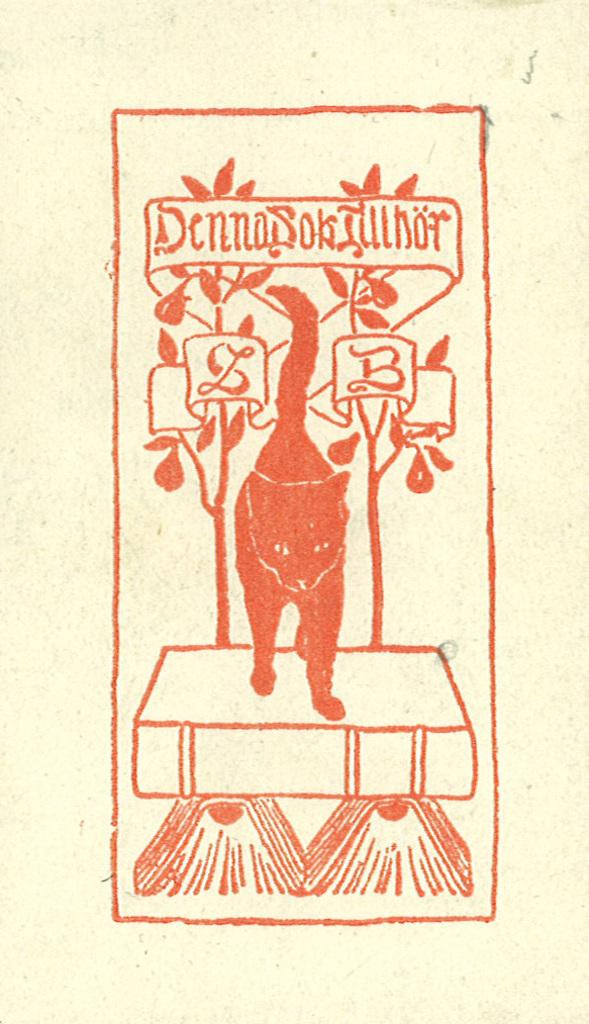What is the main subject of the drawing in the image? There is a drawing of an animal in the image. What other elements are present in the image besides the drawing? There are plants depicted in the image, as well as text and objects on a platform. How many legs does the potato have in the image? There is no potato present in the image, so it is not possible to determine the number of legs it might have. 